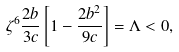<formula> <loc_0><loc_0><loc_500><loc_500>\zeta ^ { 6 } \frac { 2 b } { 3 c } \left [ 1 - \frac { 2 b ^ { 2 } } { 9 c } \right ] = \Lambda < 0 ,</formula> 